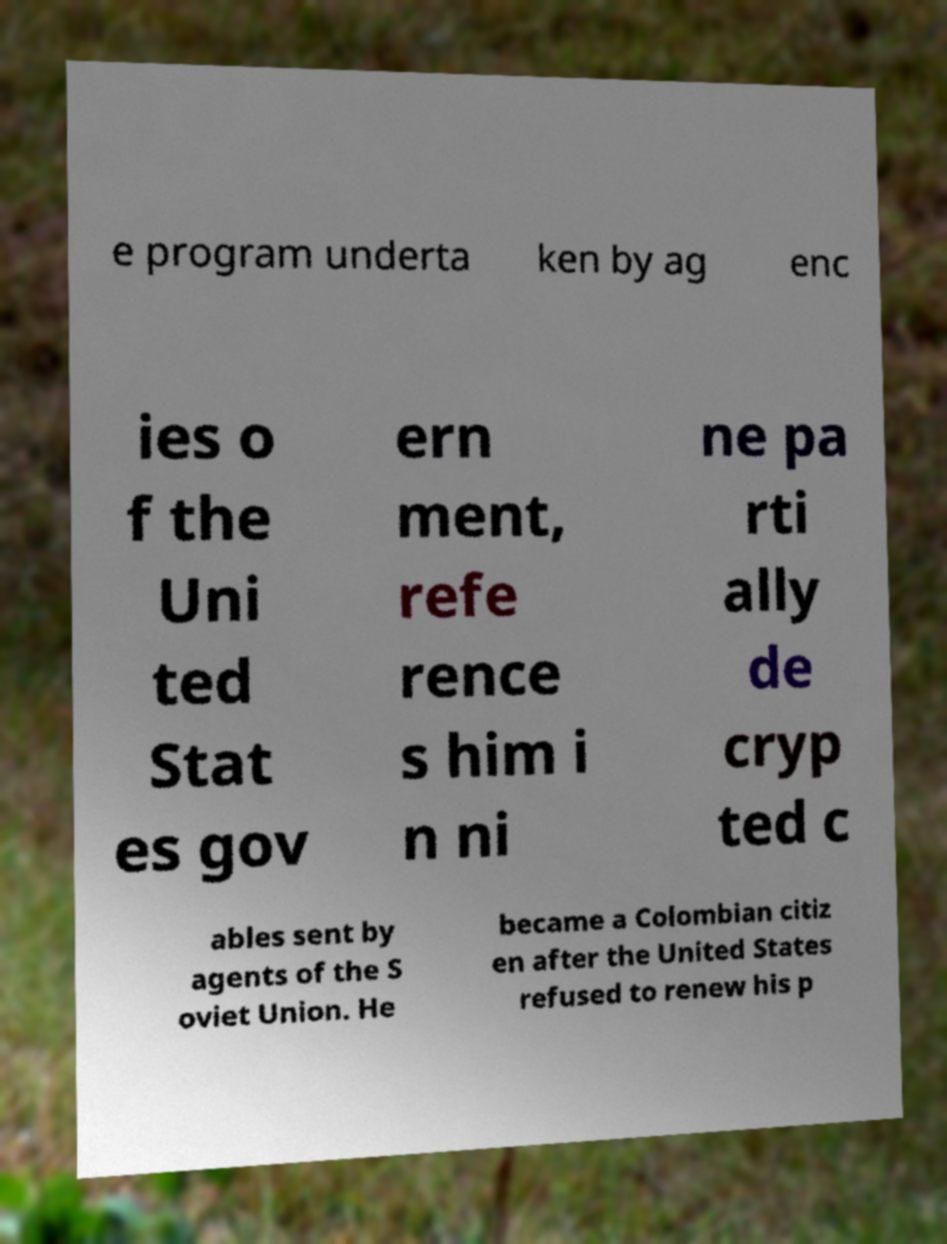Please identify and transcribe the text found in this image. e program underta ken by ag enc ies o f the Uni ted Stat es gov ern ment, refe rence s him i n ni ne pa rti ally de cryp ted c ables sent by agents of the S oviet Union. He became a Colombian citiz en after the United States refused to renew his p 